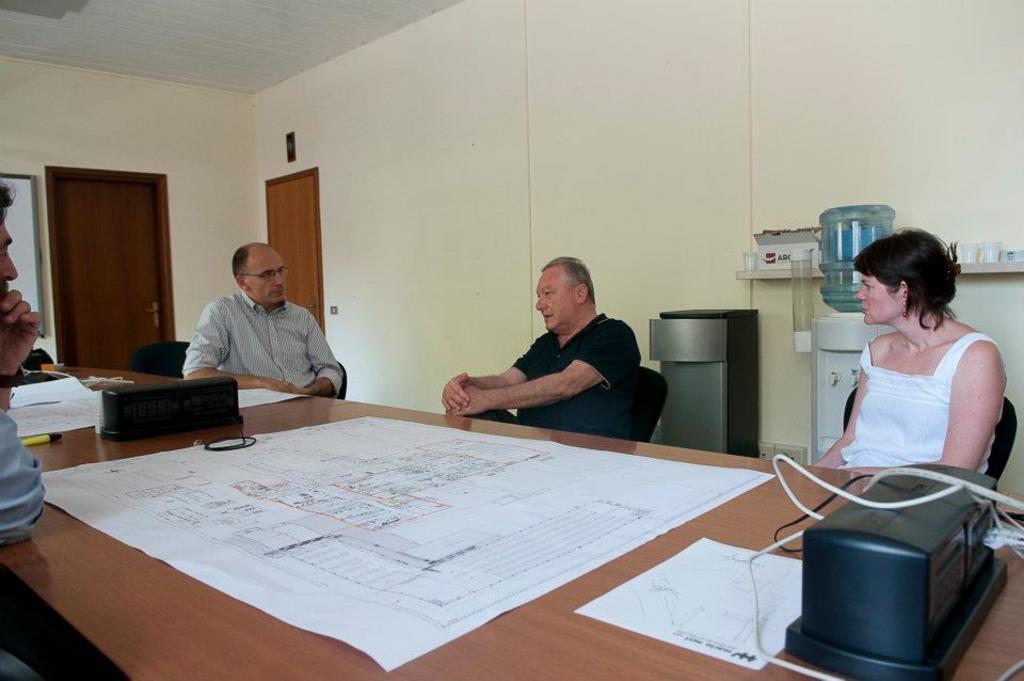Describe this image in one or two sentences. This is a ceiling. On the background we can see a wall and doors. Here we can see filter with water bubble. We can see persons sitting on chairs in front of a table and on the table we can see white colour paper chart, paper, marker. This man in black colour shirt is talking. 